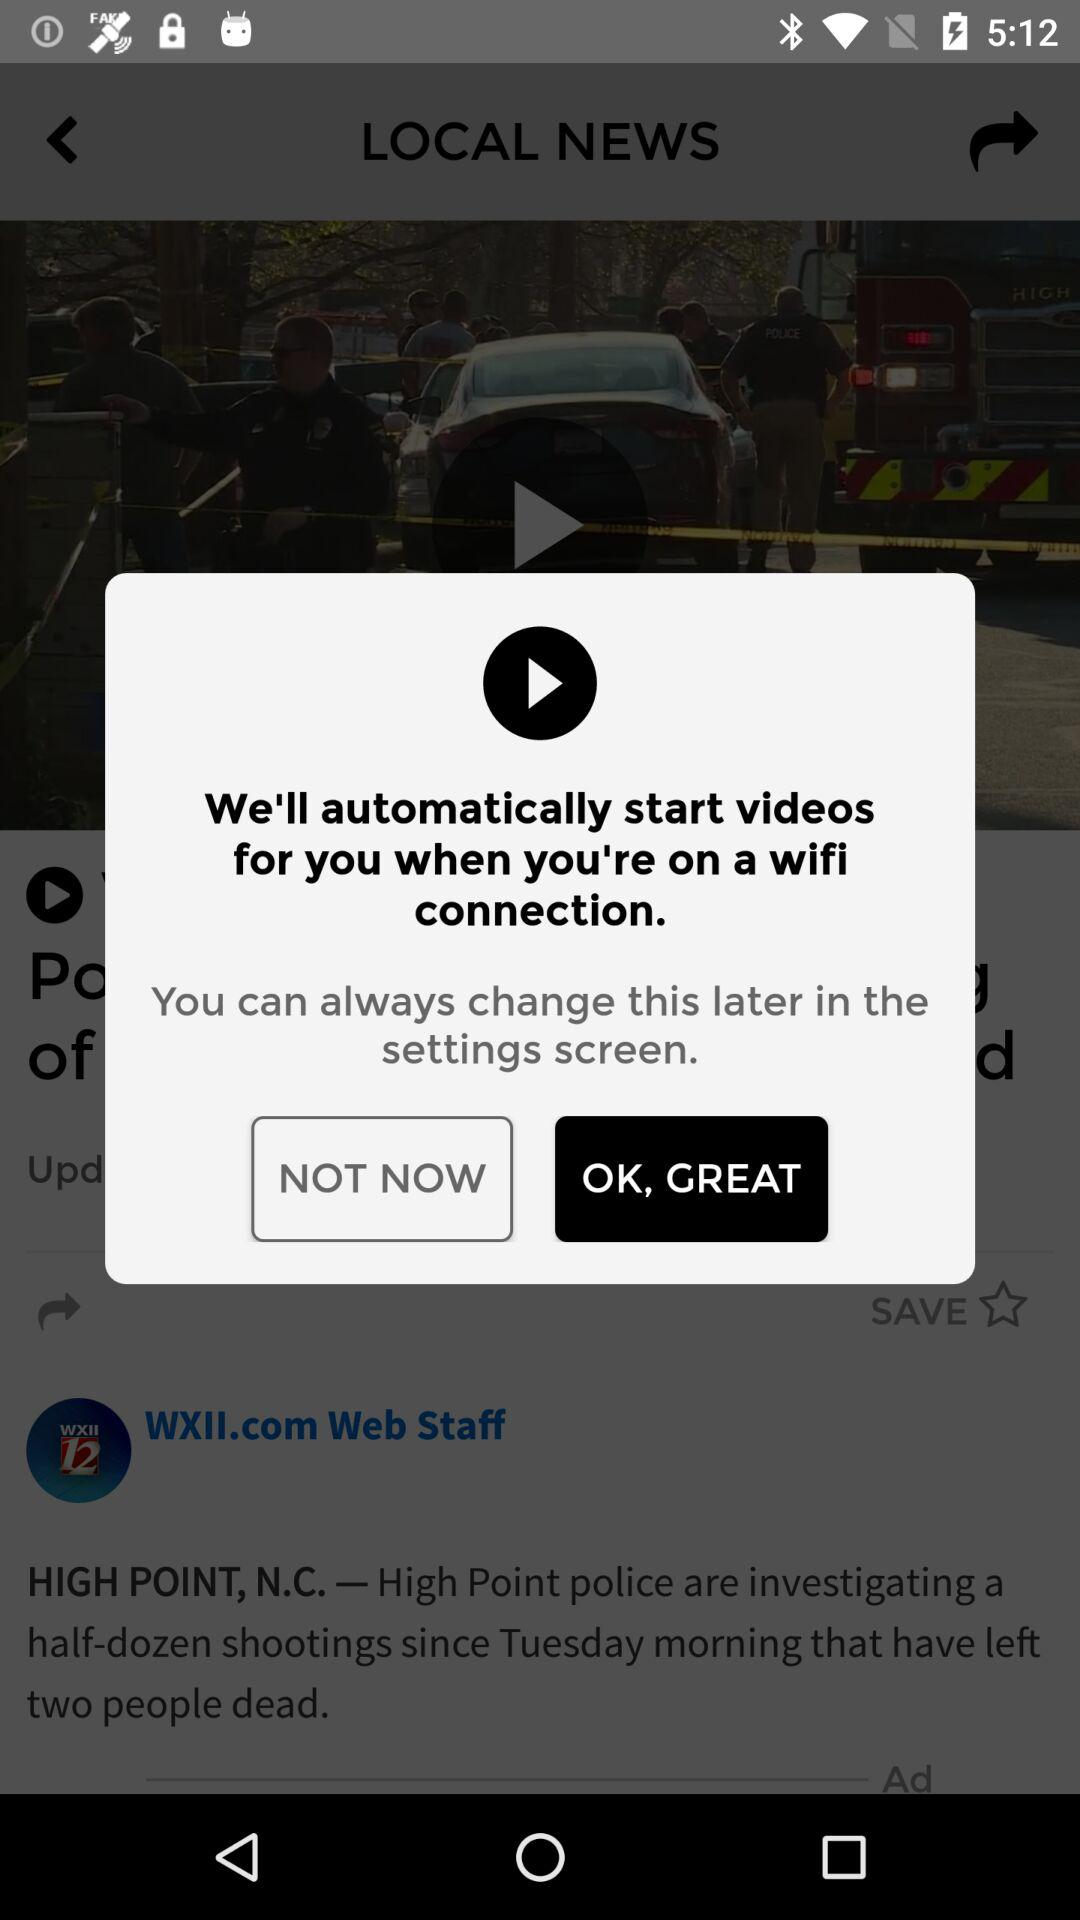When will videos start automatically? The videos will start automatically when you're on a wifi connection. 